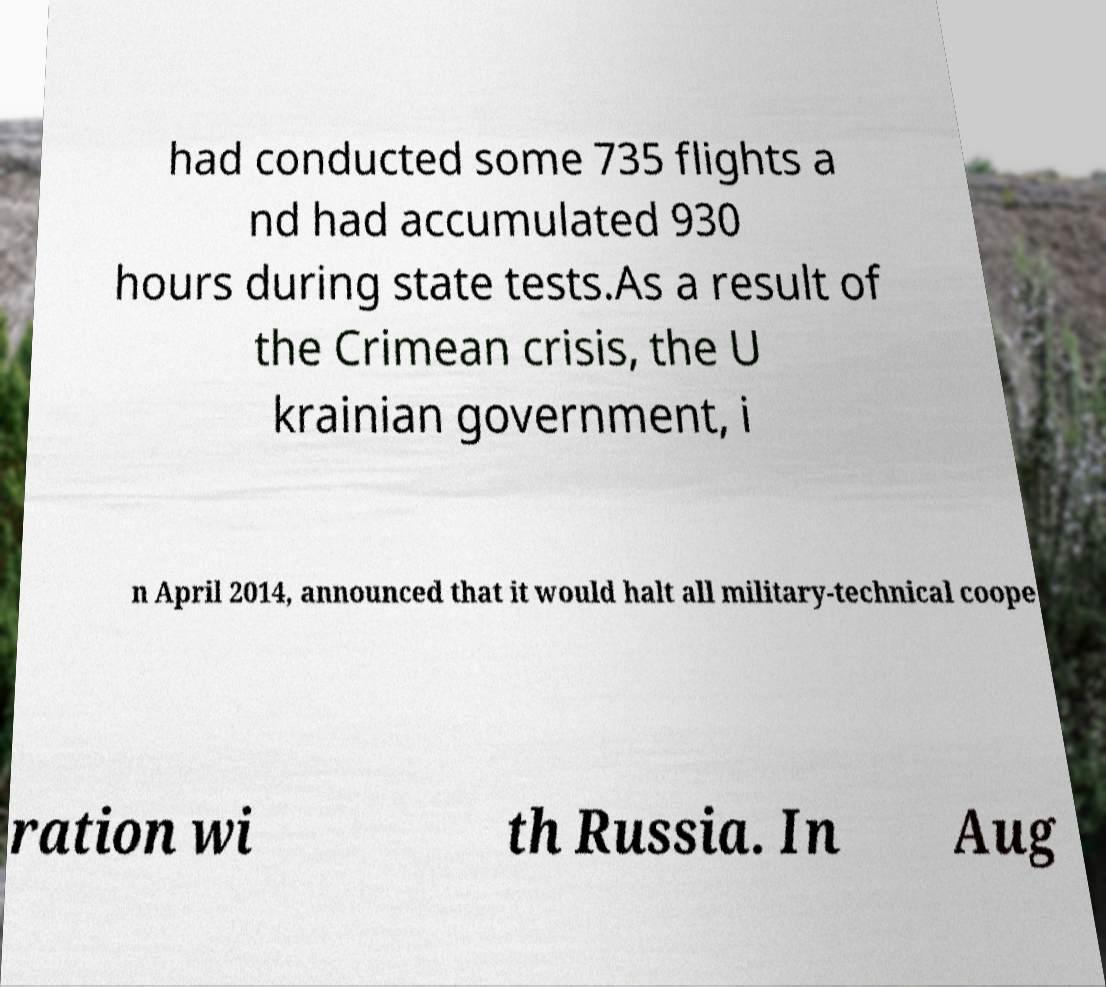Can you read and provide the text displayed in the image?This photo seems to have some interesting text. Can you extract and type it out for me? had conducted some 735 flights a nd had accumulated 930 hours during state tests.As a result of the Crimean crisis, the U krainian government, i n April 2014, announced that it would halt all military-technical coope ration wi th Russia. In Aug 